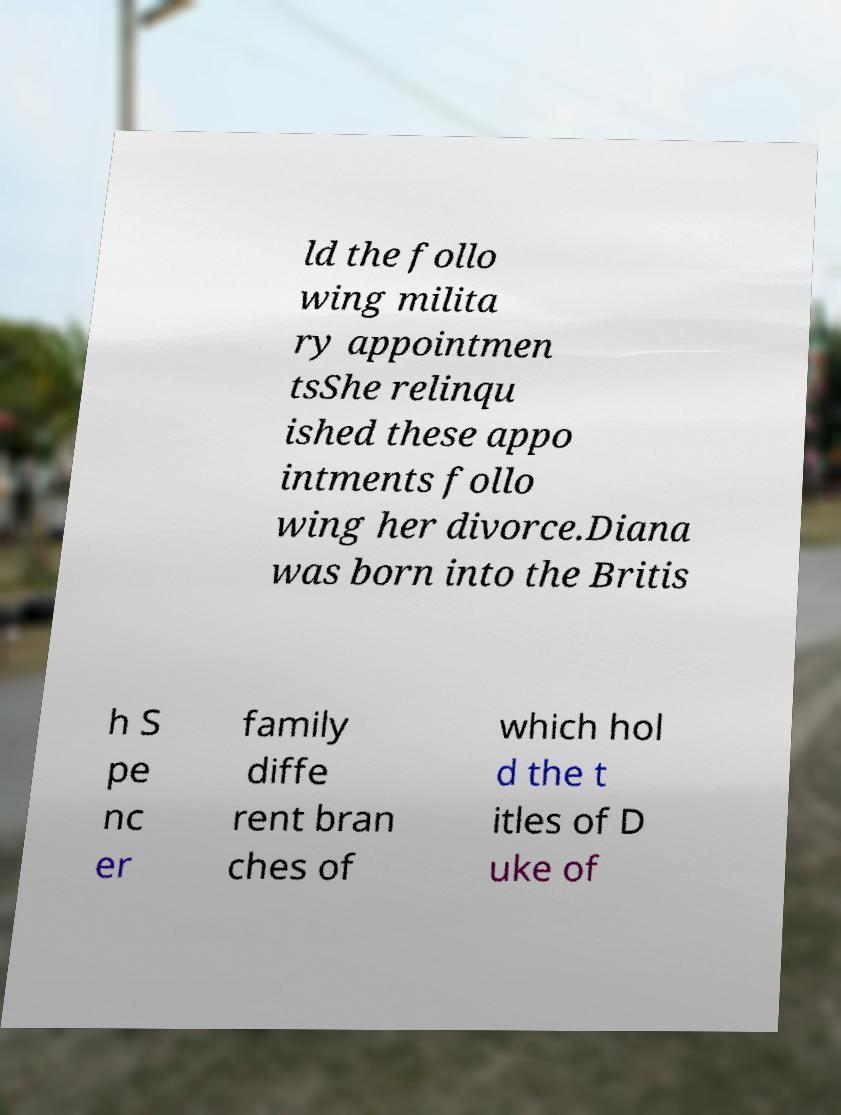I need the written content from this picture converted into text. Can you do that? ld the follo wing milita ry appointmen tsShe relinqu ished these appo intments follo wing her divorce.Diana was born into the Britis h S pe nc er family diffe rent bran ches of which hol d the t itles of D uke of 